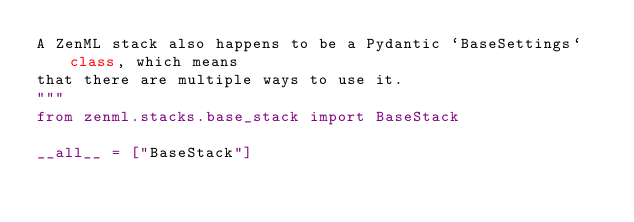<code> <loc_0><loc_0><loc_500><loc_500><_Python_>A ZenML stack also happens to be a Pydantic `BaseSettings` class, which means
that there are multiple ways to use it.
"""
from zenml.stacks.base_stack import BaseStack

__all__ = ["BaseStack"]
</code> 